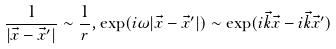Convert formula to latex. <formula><loc_0><loc_0><loc_500><loc_500>\frac { 1 } { | \vec { x } - \vec { x } ^ { \prime } | } \sim \frac { 1 } { r } , \exp ( i \omega | \vec { x } - \vec { x } ^ { \prime } | ) \sim \exp ( i \vec { k } \vec { x } - i \vec { k } \vec { x } ^ { \prime } )</formula> 